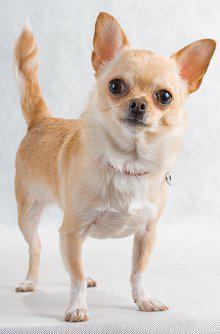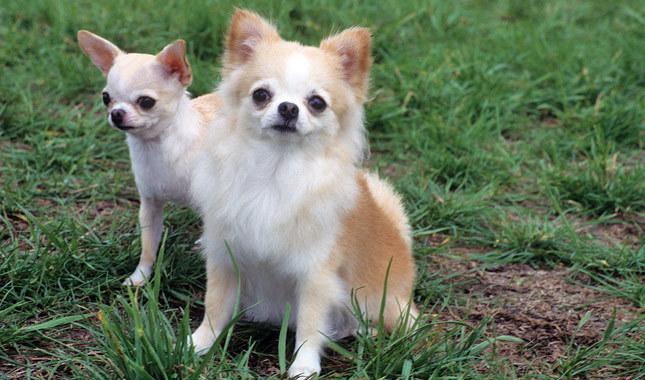The first image is the image on the left, the second image is the image on the right. Considering the images on both sides, is "There is a chihuahua on grass facing to the right and also a chihua with a darker colouring." valid? Answer yes or no. No. 